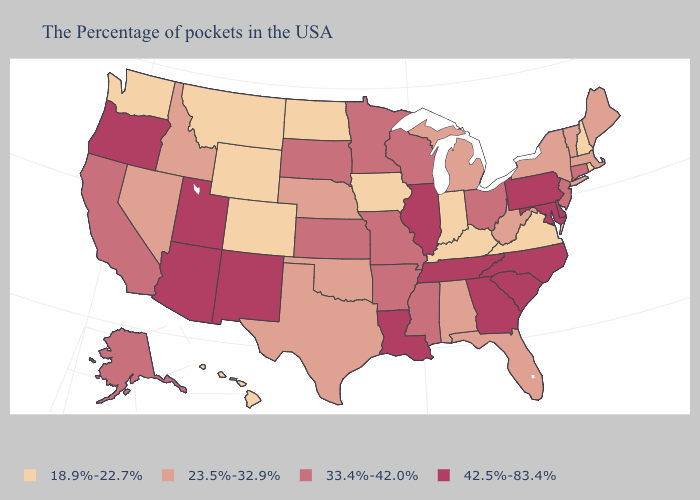Does the first symbol in the legend represent the smallest category?
Give a very brief answer. Yes. Name the states that have a value in the range 42.5%-83.4%?
Short answer required. Delaware, Maryland, Pennsylvania, North Carolina, South Carolina, Georgia, Tennessee, Illinois, Louisiana, New Mexico, Utah, Arizona, Oregon. What is the highest value in states that border Wisconsin?
Answer briefly. 42.5%-83.4%. Among the states that border Arizona , does Colorado have the lowest value?
Keep it brief. Yes. Which states have the lowest value in the USA?
Write a very short answer. Rhode Island, New Hampshire, Virginia, Kentucky, Indiana, Iowa, North Dakota, Wyoming, Colorado, Montana, Washington, Hawaii. What is the value of Montana?
Write a very short answer. 18.9%-22.7%. Among the states that border New Hampshire , which have the lowest value?
Quick response, please. Maine, Massachusetts, Vermont. Among the states that border New Mexico , which have the highest value?
Short answer required. Utah, Arizona. Name the states that have a value in the range 33.4%-42.0%?
Write a very short answer. Connecticut, New Jersey, Ohio, Wisconsin, Mississippi, Missouri, Arkansas, Minnesota, Kansas, South Dakota, California, Alaska. What is the highest value in the USA?
Write a very short answer. 42.5%-83.4%. What is the value of Indiana?
Short answer required. 18.9%-22.7%. Does Maryland have a higher value than Tennessee?
Keep it brief. No. What is the value of California?
Be succinct. 33.4%-42.0%. Name the states that have a value in the range 33.4%-42.0%?
Quick response, please. Connecticut, New Jersey, Ohio, Wisconsin, Mississippi, Missouri, Arkansas, Minnesota, Kansas, South Dakota, California, Alaska. What is the highest value in the USA?
Concise answer only. 42.5%-83.4%. 